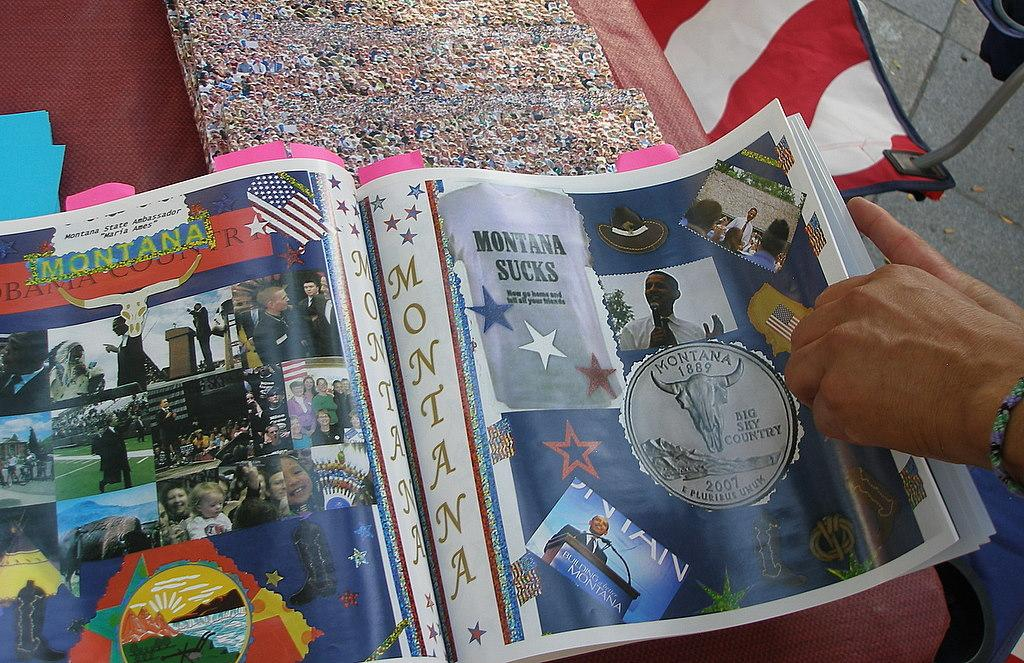<image>
Describe the image concisely. The magazine claims that Montana sucks now go home and tell your friends. 